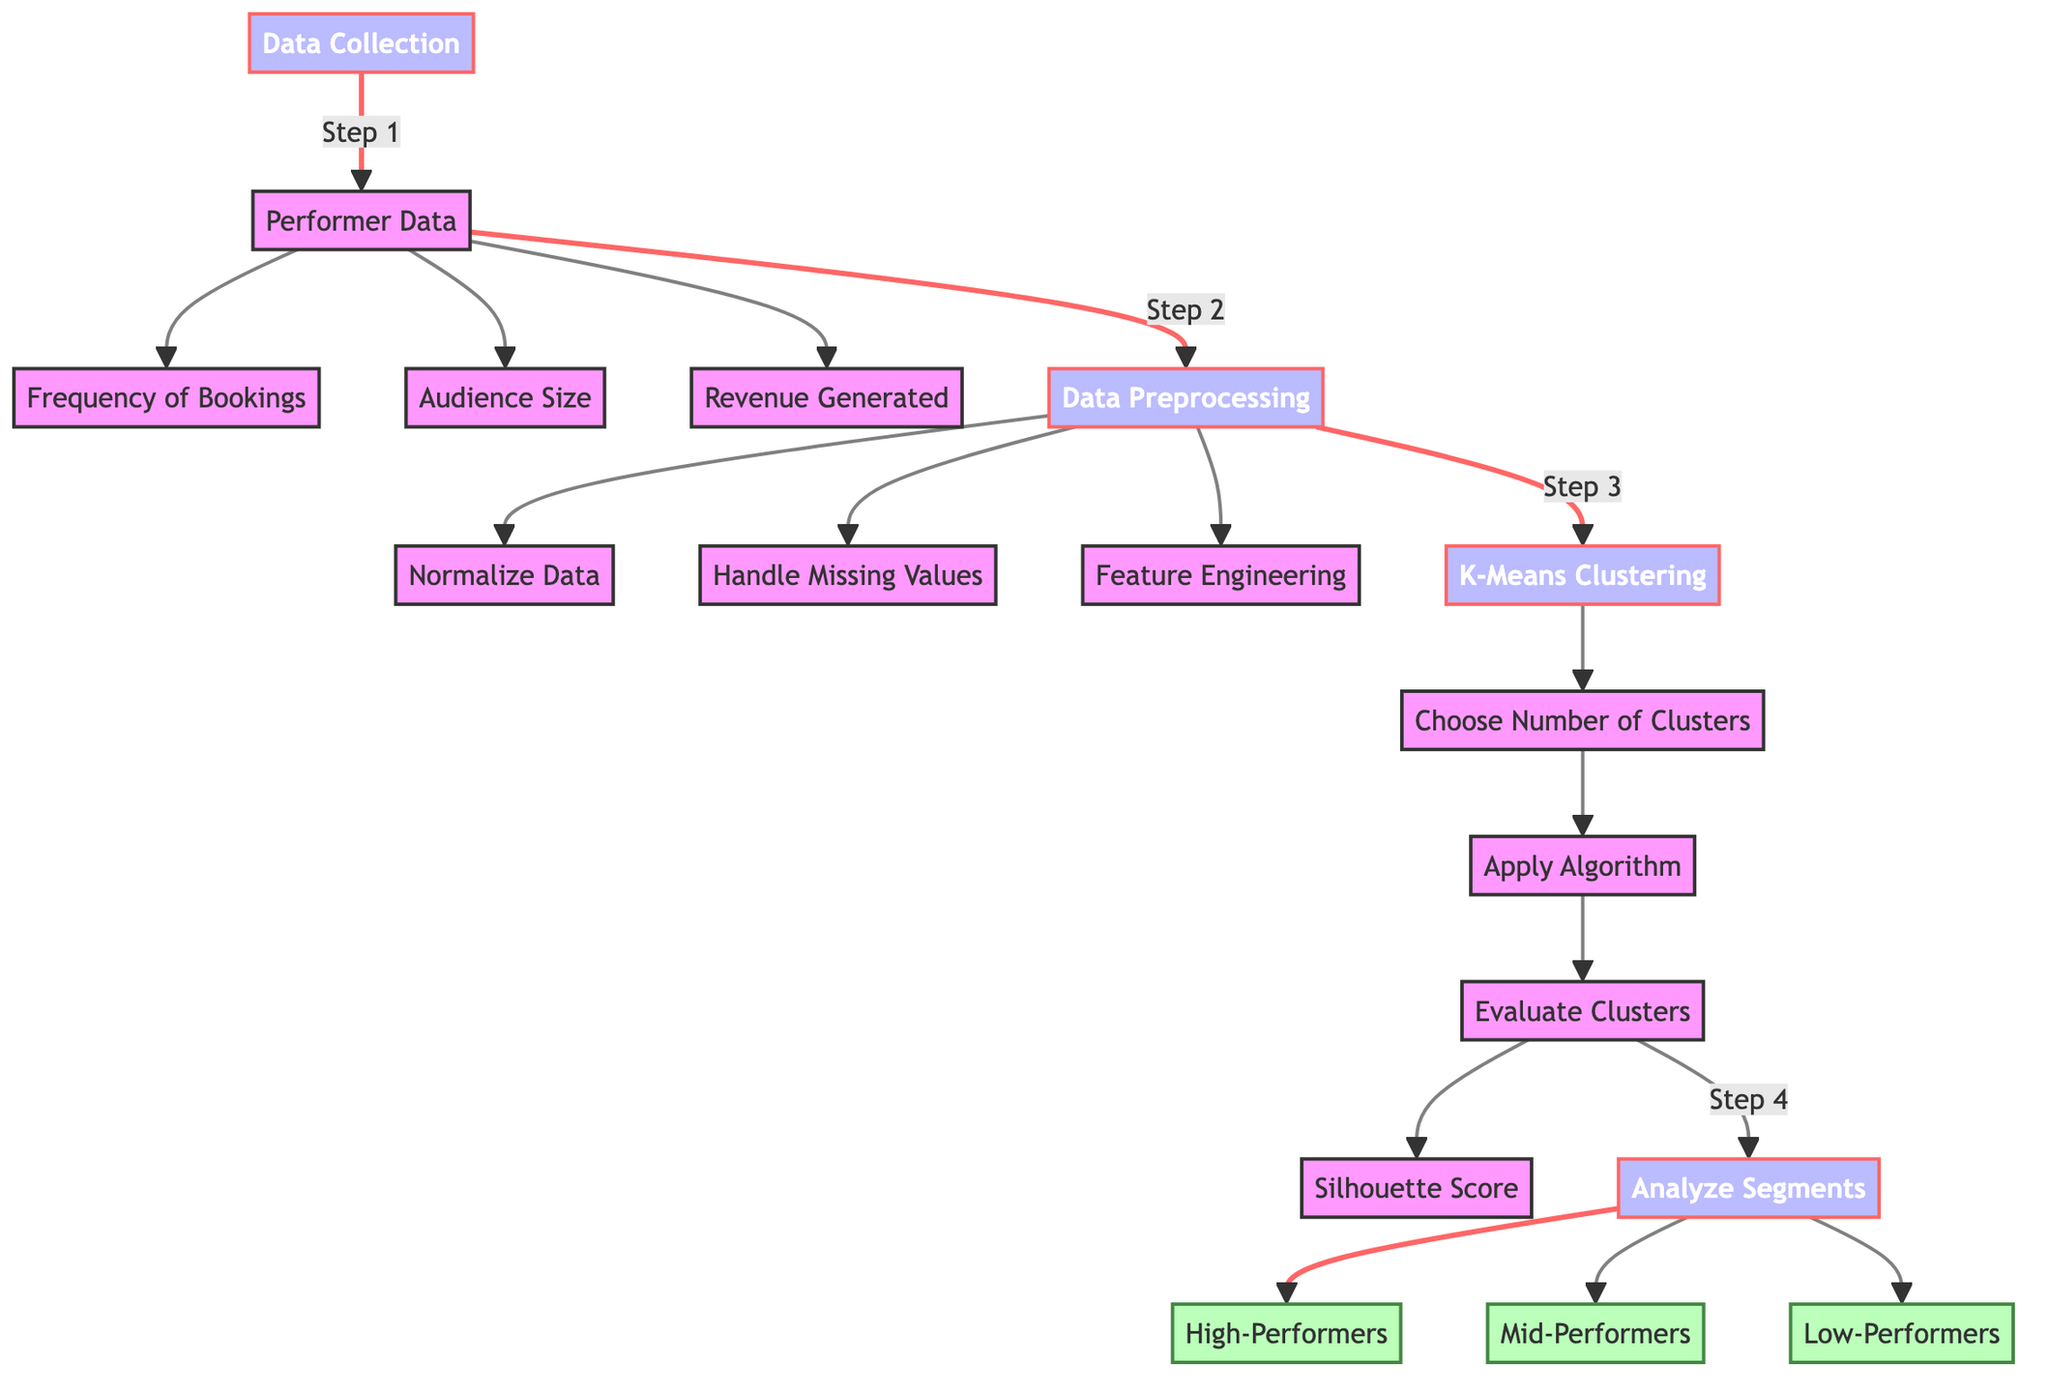What is the first step in the diagram? The first step in the diagram is labeled as "Data Collection." It initiates the process of gathering performer metrics before any analysis or preprocessing can begin.
Answer: Data Collection How many segments are analyzed in the end? The diagram indicates that there are three segments analyzed, specifically categorized as High-Performers, Mid-Performers, and Low-Performers.
Answer: Three What follows after data preprocessing? After the data preprocessing step, the next step indicated in the diagram is "K-Means Clustering." This shows that once data is preprocessed, clustering techniques are applied.
Answer: K-Means Clustering Which method is used to evaluate clusters? The method used to evaluate the clusters according to the diagram is the "Silhouette Score." This is a specific metric for assessing the quality of clustering results.
Answer: Silhouette Score What three metrics are part of the performer data? The three metrics included in the performer data are Frequency of Bookings, Audience Size, and Revenue Generated, as explicitly stated in the diagram.
Answer: Frequency of Bookings, Audience Size, Revenue Generated What is the last step before analyzing segments? The last step before analyzing the segments is evaluating the clusters. This step is crucial to assess the effectiveness of the clustering process.
Answer: Evaluate Clusters What is the purpose of feature engineering in this process? Feature engineering is part of the data preprocessing that prepares and transforms raw data into meaningful features that will enhance the clustering algorithm's performance.
Answer: Prepare and transform data Which segment represents the best performers? The segment that represents the best performers is labeled as "High-Performers," indicating that they achieve the highest success metrics in the clustering analysis.
Answer: High-Performers How is the number of clusters determined? The number of clusters is determined in the step labeled "Choose Number of Clusters," which is a critical decision in the clustering process that influences the final segmentation.
Answer: Choose Number of Clusters 